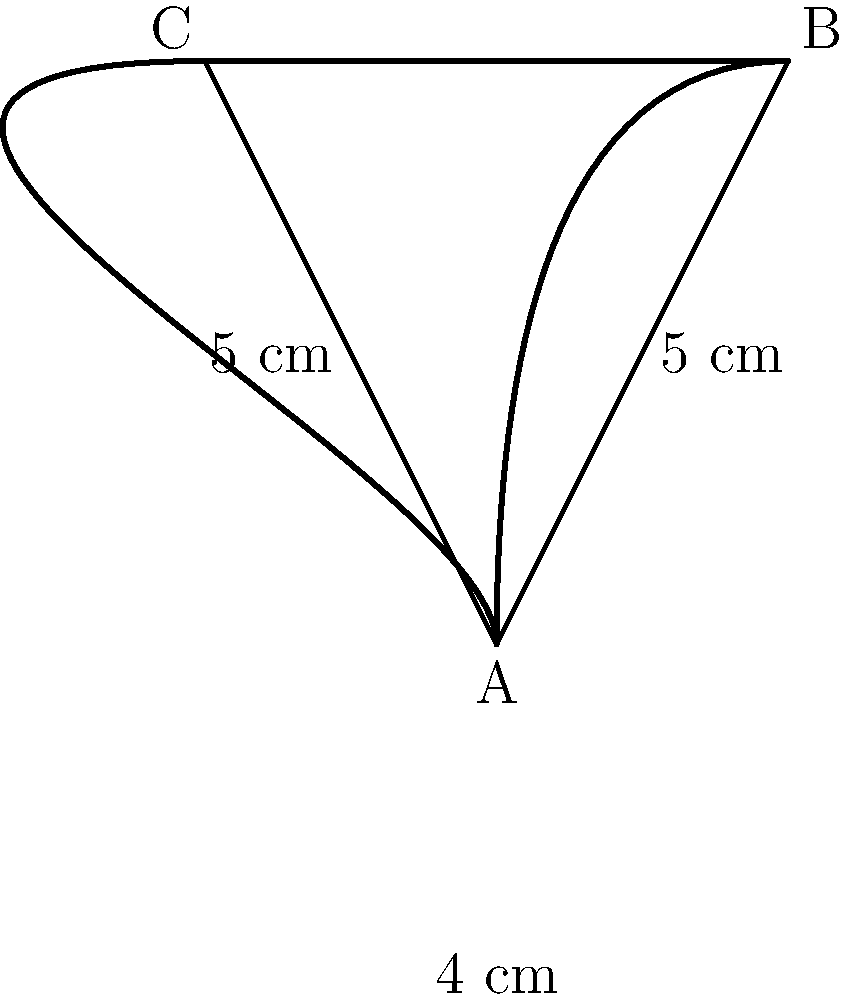Ein besonderes Glockenexemplar in Ihrer Sammlung hat die Form eines Dreiecks mit einer gebogenen Oberseite. Die beiden geraden Seiten des Dreiecks messen jeweils 5 cm, während die Basis 4 cm lang ist. Die gebogene Oberseite ist 1 cm länger als die Summe der beiden geraden Seiten. Berechnen Sie den Umfang dieser einzigartigen Glocke in Zentimetern. Um den Umfang der Glocke zu berechnen, müssen wir die Längen aller Seiten addieren:

1. Die beiden geraden Seiten:
   $2 \times 5 \text{ cm} = 10 \text{ cm}$

2. Die Basis:
   $4 \text{ cm}$

3. Die gebogene Oberseite:
   - Summe der geraden Seiten: $10 \text{ cm}$
   - Die gebogene Seite ist 1 cm länger: $10 \text{ cm} + 1 \text{ cm} = 11 \text{ cm}$

Nun addieren wir alle Seiten:
$$\text{Umfang} = 5 \text{ cm} + 5 \text{ cm} + 4 \text{ cm} + 11 \text{ cm} = 25 \text{ cm}$$
Answer: 25 cm 